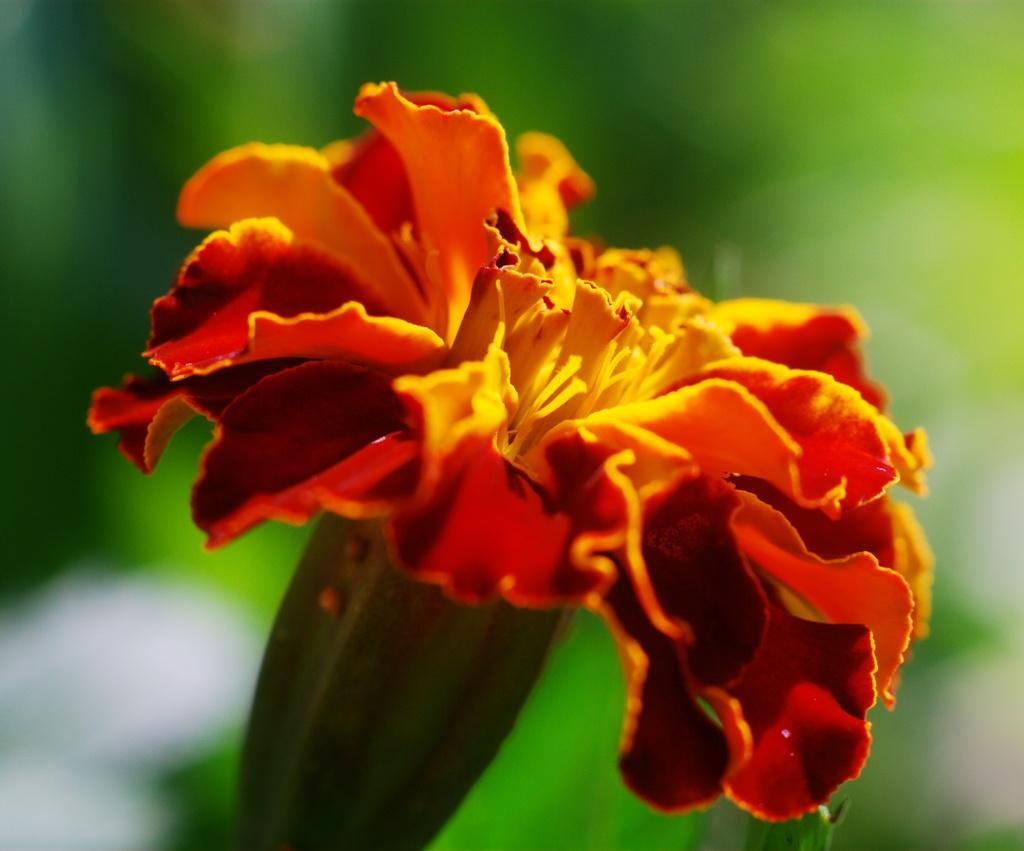Describe this image in one or two sentences. In this picture I can see a flower, and there is blur background. 